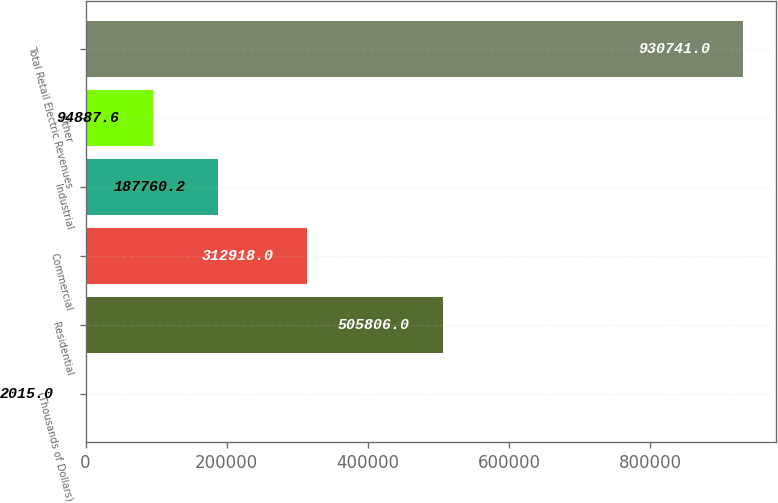Convert chart to OTSL. <chart><loc_0><loc_0><loc_500><loc_500><bar_chart><fcel>(Thousands of Dollars)<fcel>Residential<fcel>Commercial<fcel>Industrial<fcel>Other<fcel>Total Retail Electric Revenues<nl><fcel>2015<fcel>505806<fcel>312918<fcel>187760<fcel>94887.6<fcel>930741<nl></chart> 